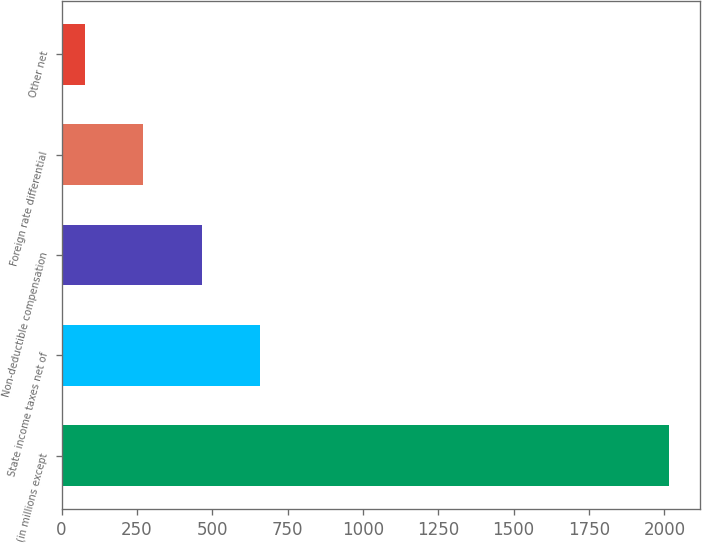Convert chart. <chart><loc_0><loc_0><loc_500><loc_500><bar_chart><fcel>(in millions except<fcel>State income taxes net of<fcel>Non-deductible compensation<fcel>Foreign rate differential<fcel>Other net<nl><fcel>2016<fcel>658.7<fcel>464.8<fcel>270.9<fcel>77<nl></chart> 